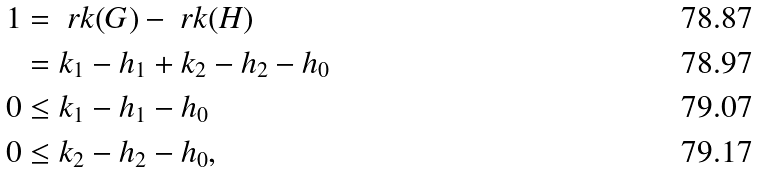<formula> <loc_0><loc_0><loc_500><loc_500>1 & = \ r k ( G ) - \ r k ( H ) \\ & = k _ { 1 } - h _ { 1 } + k _ { 2 } - h _ { 2 } - h _ { 0 } \\ 0 & \leq k _ { 1 } - h _ { 1 } - h _ { 0 } \\ 0 & \leq k _ { 2 } - h _ { 2 } - h _ { 0 } ,</formula> 